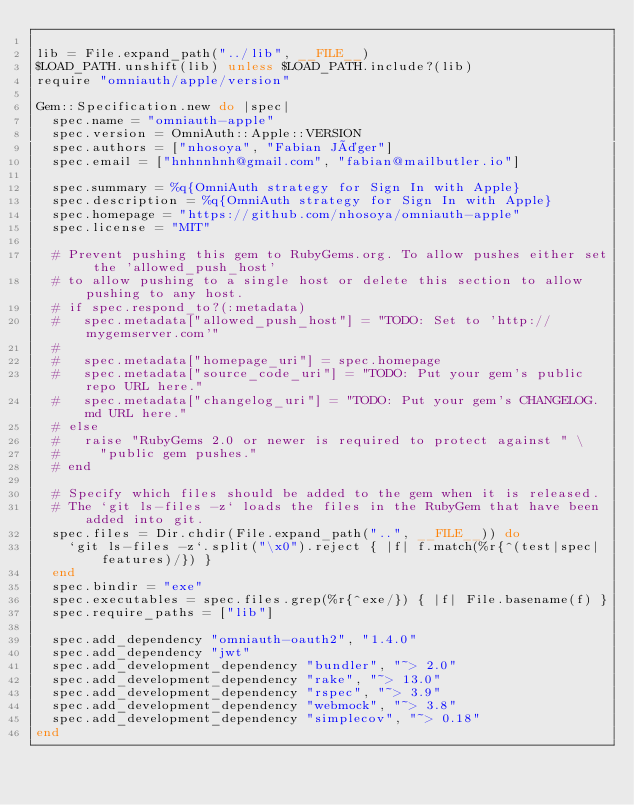<code> <loc_0><loc_0><loc_500><loc_500><_Ruby_>
lib = File.expand_path("../lib", __FILE__)
$LOAD_PATH.unshift(lib) unless $LOAD_PATH.include?(lib)
require "omniauth/apple/version"

Gem::Specification.new do |spec|
  spec.name = "omniauth-apple"
  spec.version = OmniAuth::Apple::VERSION
  spec.authors = ["nhosoya", "Fabian Jäger"]
  spec.email = ["hnhnnhnh@gmail.com", "fabian@mailbutler.io"]

  spec.summary = %q{OmniAuth strategy for Sign In with Apple}
  spec.description = %q{OmniAuth strategy for Sign In with Apple}
  spec.homepage = "https://github.com/nhosoya/omniauth-apple"
  spec.license = "MIT"

  # Prevent pushing this gem to RubyGems.org. To allow pushes either set the 'allowed_push_host'
  # to allow pushing to a single host or delete this section to allow pushing to any host.
  # if spec.respond_to?(:metadata)
  #   spec.metadata["allowed_push_host"] = "TODO: Set to 'http://mygemserver.com'"
  #
  #   spec.metadata["homepage_uri"] = spec.homepage
  #   spec.metadata["source_code_uri"] = "TODO: Put your gem's public repo URL here."
  #   spec.metadata["changelog_uri"] = "TODO: Put your gem's CHANGELOG.md URL here."
  # else
  #   raise "RubyGems 2.0 or newer is required to protect against " \
  #     "public gem pushes."
  # end

  # Specify which files should be added to the gem when it is released.
  # The `git ls-files -z` loads the files in the RubyGem that have been added into git.
  spec.files = Dir.chdir(File.expand_path("..", __FILE__)) do
    `git ls-files -z`.split("\x0").reject { |f| f.match(%r{^(test|spec|features)/}) }
  end
  spec.bindir = "exe"
  spec.executables = spec.files.grep(%r{^exe/}) { |f| File.basename(f) }
  spec.require_paths = ["lib"]

  spec.add_dependency "omniauth-oauth2", "1.4.0"
  spec.add_dependency "jwt"
  spec.add_development_dependency "bundler", "~> 2.0"
  spec.add_development_dependency "rake", "~> 13.0"
  spec.add_development_dependency "rspec", "~> 3.9"
  spec.add_development_dependency "webmock", "~> 3.8"
  spec.add_development_dependency "simplecov", "~> 0.18"
end
</code> 